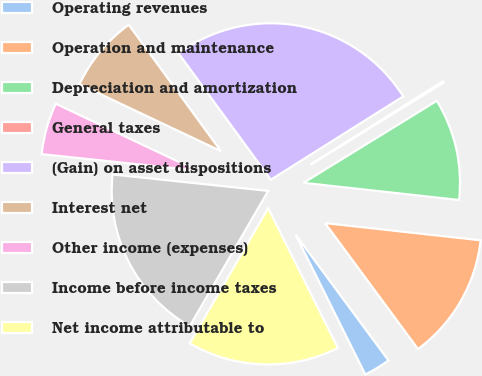<chart> <loc_0><loc_0><loc_500><loc_500><pie_chart><fcel>Operating revenues<fcel>Operation and maintenance<fcel>Depreciation and amortization<fcel>General taxes<fcel>(Gain) on asset dispositions<fcel>Interest net<fcel>Other income (expenses)<fcel>Income before income taxes<fcel>Net income attributable to<nl><fcel>2.76%<fcel>13.13%<fcel>10.53%<fcel>0.16%<fcel>26.09%<fcel>7.94%<fcel>5.35%<fcel>18.31%<fcel>15.72%<nl></chart> 